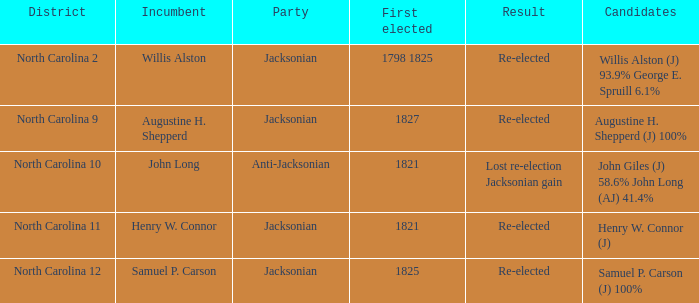Name the result for  augustine h. shepperd (j) 100% Re-elected. 